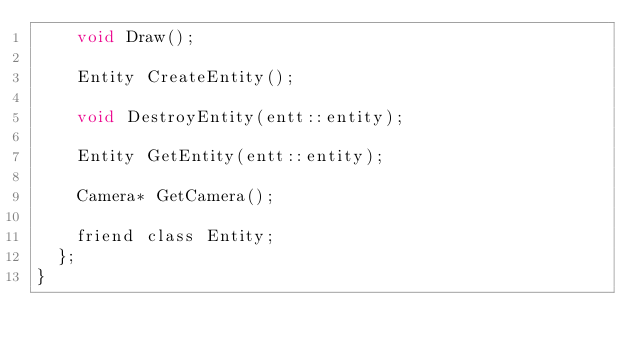Convert code to text. <code><loc_0><loc_0><loc_500><loc_500><_C_>		void Draw();

		Entity CreateEntity();

		void DestroyEntity(entt::entity);

		Entity GetEntity(entt::entity);

		Camera* GetCamera();

		friend class Entity;
	};
}
</code> 